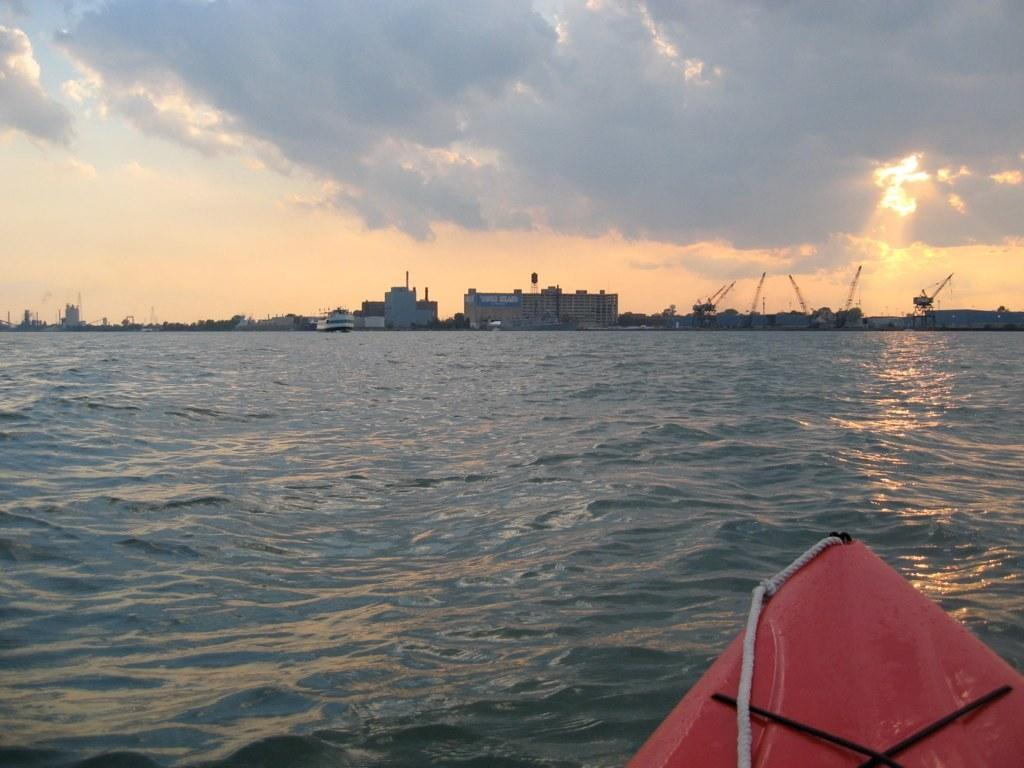What is located in the foreground of the picture? There is a boat in the foreground of the picture. What is the primary element in the foreground of the picture? There is water in the foreground of the picture. What can be seen in the center of the picture? There are buildings, trees, and cranes in the center of the picture. What is visible on the left side of the picture? Sun rays are visible on the left side of the picture. How would you describe the sky in the picture? The sky is cloudy. What type of story is being told by the pocket in the picture? There is no pocket present in the image, so no story can be associated with it. How does the sleet affect the boat in the picture? There is no mention of sleet in the image, so its effect on the boat cannot be determined. 